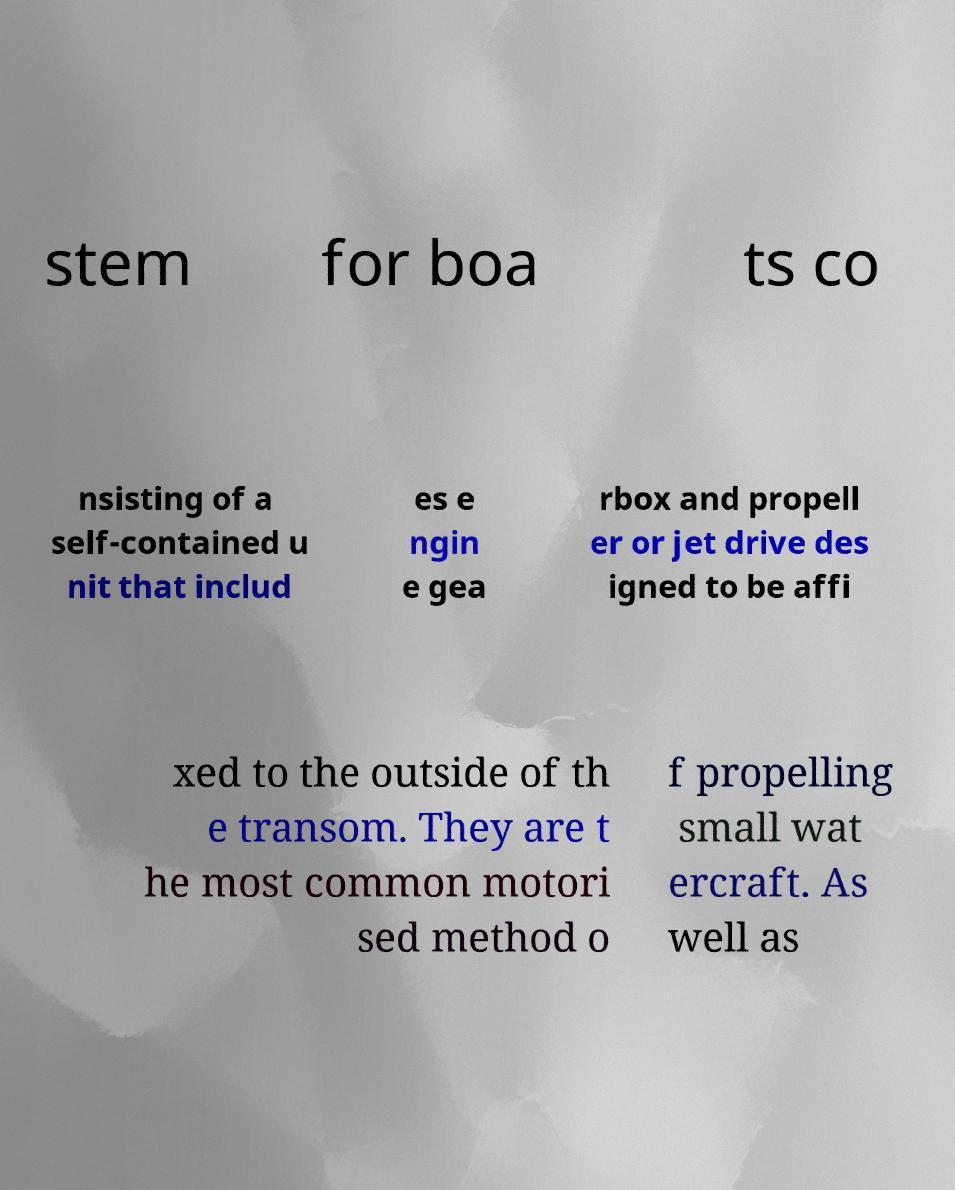Could you extract and type out the text from this image? stem for boa ts co nsisting of a self-contained u nit that includ es e ngin e gea rbox and propell er or jet drive des igned to be affi xed to the outside of th e transom. They are t he most common motori sed method o f propelling small wat ercraft. As well as 